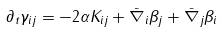<formula> <loc_0><loc_0><loc_500><loc_500>\partial _ { t } \gamma _ { i j } = - 2 \alpha K _ { i j } + \bar { \nabla } _ { i } \beta _ { j } + \bar { \nabla } _ { j } \beta _ { i }</formula> 